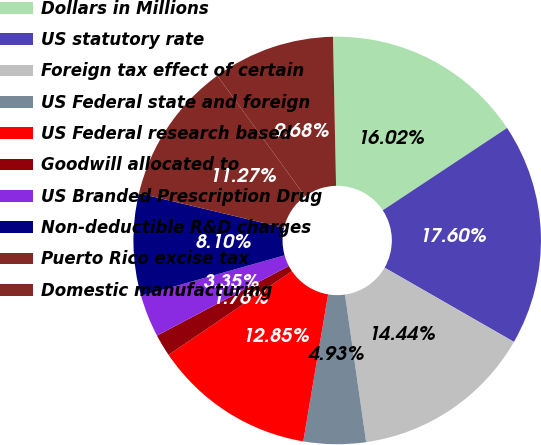Convert chart to OTSL. <chart><loc_0><loc_0><loc_500><loc_500><pie_chart><fcel>Dollars in Millions<fcel>US statutory rate<fcel>Foreign tax effect of certain<fcel>US Federal state and foreign<fcel>US Federal research based<fcel>Goodwill allocated to<fcel>US Branded Prescription Drug<fcel>Non-deductible R&D charges<fcel>Puerto Rico excise tax<fcel>Domestic manufacturing<nl><fcel>16.02%<fcel>17.6%<fcel>14.44%<fcel>4.93%<fcel>12.85%<fcel>1.76%<fcel>3.35%<fcel>8.1%<fcel>11.27%<fcel>9.68%<nl></chart> 